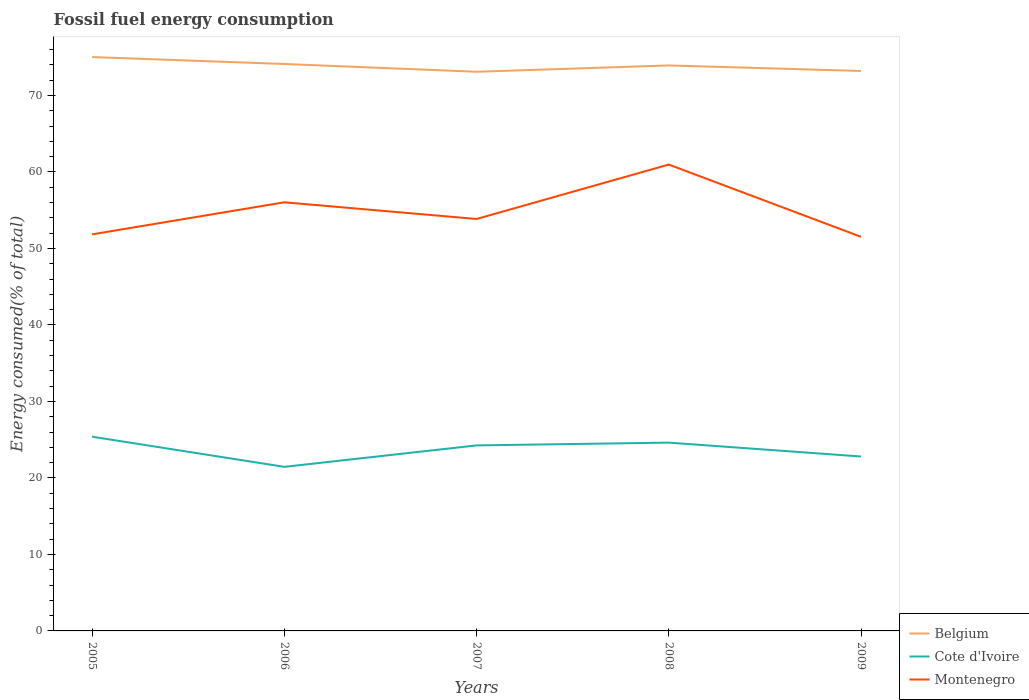Does the line corresponding to Cote d'Ivoire intersect with the line corresponding to Montenegro?
Make the answer very short. No. Across all years, what is the maximum percentage of energy consumed in Cote d'Ivoire?
Your response must be concise. 21.45. What is the total percentage of energy consumed in Belgium in the graph?
Provide a short and direct response. 1.92. What is the difference between the highest and the second highest percentage of energy consumed in Belgium?
Your answer should be very brief. 1.92. What is the difference between the highest and the lowest percentage of energy consumed in Belgium?
Provide a short and direct response. 3. How many lines are there?
Ensure brevity in your answer.  3. How many years are there in the graph?
Your answer should be compact. 5. Where does the legend appear in the graph?
Keep it short and to the point. Bottom right. What is the title of the graph?
Your answer should be very brief. Fossil fuel energy consumption. What is the label or title of the Y-axis?
Offer a terse response. Energy consumed(% of total). What is the Energy consumed(% of total) of Belgium in 2005?
Provide a succinct answer. 75.02. What is the Energy consumed(% of total) of Cote d'Ivoire in 2005?
Make the answer very short. 25.39. What is the Energy consumed(% of total) of Montenegro in 2005?
Offer a very short reply. 51.85. What is the Energy consumed(% of total) of Belgium in 2006?
Make the answer very short. 74.12. What is the Energy consumed(% of total) in Cote d'Ivoire in 2006?
Keep it short and to the point. 21.45. What is the Energy consumed(% of total) in Montenegro in 2006?
Give a very brief answer. 56.03. What is the Energy consumed(% of total) in Belgium in 2007?
Your answer should be very brief. 73.1. What is the Energy consumed(% of total) of Cote d'Ivoire in 2007?
Make the answer very short. 24.25. What is the Energy consumed(% of total) in Montenegro in 2007?
Ensure brevity in your answer.  53.86. What is the Energy consumed(% of total) of Belgium in 2008?
Ensure brevity in your answer.  73.93. What is the Energy consumed(% of total) in Cote d'Ivoire in 2008?
Give a very brief answer. 24.62. What is the Energy consumed(% of total) in Montenegro in 2008?
Your answer should be compact. 60.97. What is the Energy consumed(% of total) of Belgium in 2009?
Your answer should be compact. 73.21. What is the Energy consumed(% of total) of Cote d'Ivoire in 2009?
Provide a short and direct response. 22.8. What is the Energy consumed(% of total) in Montenegro in 2009?
Keep it short and to the point. 51.53. Across all years, what is the maximum Energy consumed(% of total) in Belgium?
Your response must be concise. 75.02. Across all years, what is the maximum Energy consumed(% of total) in Cote d'Ivoire?
Offer a very short reply. 25.39. Across all years, what is the maximum Energy consumed(% of total) of Montenegro?
Keep it short and to the point. 60.97. Across all years, what is the minimum Energy consumed(% of total) in Belgium?
Provide a succinct answer. 73.1. Across all years, what is the minimum Energy consumed(% of total) of Cote d'Ivoire?
Your answer should be compact. 21.45. Across all years, what is the minimum Energy consumed(% of total) in Montenegro?
Provide a short and direct response. 51.53. What is the total Energy consumed(% of total) in Belgium in the graph?
Give a very brief answer. 369.37. What is the total Energy consumed(% of total) in Cote d'Ivoire in the graph?
Give a very brief answer. 118.51. What is the total Energy consumed(% of total) of Montenegro in the graph?
Provide a succinct answer. 274.23. What is the difference between the Energy consumed(% of total) of Belgium in 2005 and that in 2006?
Keep it short and to the point. 0.9. What is the difference between the Energy consumed(% of total) in Cote d'Ivoire in 2005 and that in 2006?
Make the answer very short. 3.94. What is the difference between the Energy consumed(% of total) in Montenegro in 2005 and that in 2006?
Give a very brief answer. -4.19. What is the difference between the Energy consumed(% of total) in Belgium in 2005 and that in 2007?
Provide a succinct answer. 1.92. What is the difference between the Energy consumed(% of total) of Cote d'Ivoire in 2005 and that in 2007?
Ensure brevity in your answer.  1.14. What is the difference between the Energy consumed(% of total) of Montenegro in 2005 and that in 2007?
Ensure brevity in your answer.  -2.01. What is the difference between the Energy consumed(% of total) of Belgium in 2005 and that in 2008?
Give a very brief answer. 1.1. What is the difference between the Energy consumed(% of total) in Cote d'Ivoire in 2005 and that in 2008?
Provide a short and direct response. 0.77. What is the difference between the Energy consumed(% of total) of Montenegro in 2005 and that in 2008?
Offer a terse response. -9.12. What is the difference between the Energy consumed(% of total) in Belgium in 2005 and that in 2009?
Provide a short and direct response. 1.82. What is the difference between the Energy consumed(% of total) of Cote d'Ivoire in 2005 and that in 2009?
Keep it short and to the point. 2.59. What is the difference between the Energy consumed(% of total) in Montenegro in 2005 and that in 2009?
Your response must be concise. 0.32. What is the difference between the Energy consumed(% of total) in Belgium in 2006 and that in 2007?
Offer a terse response. 1.02. What is the difference between the Energy consumed(% of total) in Cote d'Ivoire in 2006 and that in 2007?
Your answer should be very brief. -2.8. What is the difference between the Energy consumed(% of total) in Montenegro in 2006 and that in 2007?
Your response must be concise. 2.18. What is the difference between the Energy consumed(% of total) in Belgium in 2006 and that in 2008?
Offer a terse response. 0.19. What is the difference between the Energy consumed(% of total) in Cote d'Ivoire in 2006 and that in 2008?
Provide a succinct answer. -3.17. What is the difference between the Energy consumed(% of total) of Montenegro in 2006 and that in 2008?
Provide a succinct answer. -4.93. What is the difference between the Energy consumed(% of total) of Belgium in 2006 and that in 2009?
Provide a succinct answer. 0.91. What is the difference between the Energy consumed(% of total) in Cote d'Ivoire in 2006 and that in 2009?
Provide a short and direct response. -1.35. What is the difference between the Energy consumed(% of total) in Montenegro in 2006 and that in 2009?
Make the answer very short. 4.51. What is the difference between the Energy consumed(% of total) of Belgium in 2007 and that in 2008?
Your answer should be very brief. -0.83. What is the difference between the Energy consumed(% of total) in Cote d'Ivoire in 2007 and that in 2008?
Your response must be concise. -0.36. What is the difference between the Energy consumed(% of total) of Montenegro in 2007 and that in 2008?
Your response must be concise. -7.11. What is the difference between the Energy consumed(% of total) of Belgium in 2007 and that in 2009?
Ensure brevity in your answer.  -0.1. What is the difference between the Energy consumed(% of total) of Cote d'Ivoire in 2007 and that in 2009?
Ensure brevity in your answer.  1.45. What is the difference between the Energy consumed(% of total) of Montenegro in 2007 and that in 2009?
Provide a short and direct response. 2.33. What is the difference between the Energy consumed(% of total) of Belgium in 2008 and that in 2009?
Provide a succinct answer. 0.72. What is the difference between the Energy consumed(% of total) in Cote d'Ivoire in 2008 and that in 2009?
Provide a succinct answer. 1.82. What is the difference between the Energy consumed(% of total) of Montenegro in 2008 and that in 2009?
Your response must be concise. 9.44. What is the difference between the Energy consumed(% of total) in Belgium in 2005 and the Energy consumed(% of total) in Cote d'Ivoire in 2006?
Your response must be concise. 53.57. What is the difference between the Energy consumed(% of total) in Belgium in 2005 and the Energy consumed(% of total) in Montenegro in 2006?
Make the answer very short. 18.99. What is the difference between the Energy consumed(% of total) in Cote d'Ivoire in 2005 and the Energy consumed(% of total) in Montenegro in 2006?
Ensure brevity in your answer.  -30.64. What is the difference between the Energy consumed(% of total) in Belgium in 2005 and the Energy consumed(% of total) in Cote d'Ivoire in 2007?
Ensure brevity in your answer.  50.77. What is the difference between the Energy consumed(% of total) of Belgium in 2005 and the Energy consumed(% of total) of Montenegro in 2007?
Give a very brief answer. 21.17. What is the difference between the Energy consumed(% of total) of Cote d'Ivoire in 2005 and the Energy consumed(% of total) of Montenegro in 2007?
Make the answer very short. -28.46. What is the difference between the Energy consumed(% of total) in Belgium in 2005 and the Energy consumed(% of total) in Cote d'Ivoire in 2008?
Your response must be concise. 50.41. What is the difference between the Energy consumed(% of total) in Belgium in 2005 and the Energy consumed(% of total) in Montenegro in 2008?
Your answer should be compact. 14.05. What is the difference between the Energy consumed(% of total) in Cote d'Ivoire in 2005 and the Energy consumed(% of total) in Montenegro in 2008?
Give a very brief answer. -35.58. What is the difference between the Energy consumed(% of total) of Belgium in 2005 and the Energy consumed(% of total) of Cote d'Ivoire in 2009?
Your response must be concise. 52.22. What is the difference between the Energy consumed(% of total) of Belgium in 2005 and the Energy consumed(% of total) of Montenegro in 2009?
Provide a short and direct response. 23.5. What is the difference between the Energy consumed(% of total) of Cote d'Ivoire in 2005 and the Energy consumed(% of total) of Montenegro in 2009?
Offer a terse response. -26.13. What is the difference between the Energy consumed(% of total) in Belgium in 2006 and the Energy consumed(% of total) in Cote d'Ivoire in 2007?
Offer a very short reply. 49.86. What is the difference between the Energy consumed(% of total) in Belgium in 2006 and the Energy consumed(% of total) in Montenegro in 2007?
Offer a terse response. 20.26. What is the difference between the Energy consumed(% of total) in Cote d'Ivoire in 2006 and the Energy consumed(% of total) in Montenegro in 2007?
Your answer should be very brief. -32.41. What is the difference between the Energy consumed(% of total) of Belgium in 2006 and the Energy consumed(% of total) of Cote d'Ivoire in 2008?
Offer a very short reply. 49.5. What is the difference between the Energy consumed(% of total) in Belgium in 2006 and the Energy consumed(% of total) in Montenegro in 2008?
Your answer should be very brief. 13.15. What is the difference between the Energy consumed(% of total) in Cote d'Ivoire in 2006 and the Energy consumed(% of total) in Montenegro in 2008?
Your answer should be very brief. -39.52. What is the difference between the Energy consumed(% of total) in Belgium in 2006 and the Energy consumed(% of total) in Cote d'Ivoire in 2009?
Your response must be concise. 51.32. What is the difference between the Energy consumed(% of total) of Belgium in 2006 and the Energy consumed(% of total) of Montenegro in 2009?
Give a very brief answer. 22.59. What is the difference between the Energy consumed(% of total) of Cote d'Ivoire in 2006 and the Energy consumed(% of total) of Montenegro in 2009?
Make the answer very short. -30.08. What is the difference between the Energy consumed(% of total) of Belgium in 2007 and the Energy consumed(% of total) of Cote d'Ivoire in 2008?
Keep it short and to the point. 48.48. What is the difference between the Energy consumed(% of total) in Belgium in 2007 and the Energy consumed(% of total) in Montenegro in 2008?
Give a very brief answer. 12.13. What is the difference between the Energy consumed(% of total) of Cote d'Ivoire in 2007 and the Energy consumed(% of total) of Montenegro in 2008?
Your answer should be compact. -36.72. What is the difference between the Energy consumed(% of total) of Belgium in 2007 and the Energy consumed(% of total) of Cote d'Ivoire in 2009?
Your answer should be very brief. 50.3. What is the difference between the Energy consumed(% of total) in Belgium in 2007 and the Energy consumed(% of total) in Montenegro in 2009?
Provide a succinct answer. 21.58. What is the difference between the Energy consumed(% of total) in Cote d'Ivoire in 2007 and the Energy consumed(% of total) in Montenegro in 2009?
Provide a succinct answer. -27.27. What is the difference between the Energy consumed(% of total) of Belgium in 2008 and the Energy consumed(% of total) of Cote d'Ivoire in 2009?
Offer a terse response. 51.13. What is the difference between the Energy consumed(% of total) of Belgium in 2008 and the Energy consumed(% of total) of Montenegro in 2009?
Give a very brief answer. 22.4. What is the difference between the Energy consumed(% of total) in Cote d'Ivoire in 2008 and the Energy consumed(% of total) in Montenegro in 2009?
Provide a succinct answer. -26.91. What is the average Energy consumed(% of total) of Belgium per year?
Your answer should be compact. 73.87. What is the average Energy consumed(% of total) of Cote d'Ivoire per year?
Your answer should be compact. 23.7. What is the average Energy consumed(% of total) in Montenegro per year?
Your answer should be very brief. 54.85. In the year 2005, what is the difference between the Energy consumed(% of total) in Belgium and Energy consumed(% of total) in Cote d'Ivoire?
Provide a succinct answer. 49.63. In the year 2005, what is the difference between the Energy consumed(% of total) in Belgium and Energy consumed(% of total) in Montenegro?
Make the answer very short. 23.18. In the year 2005, what is the difference between the Energy consumed(% of total) in Cote d'Ivoire and Energy consumed(% of total) in Montenegro?
Ensure brevity in your answer.  -26.46. In the year 2006, what is the difference between the Energy consumed(% of total) in Belgium and Energy consumed(% of total) in Cote d'Ivoire?
Your answer should be very brief. 52.67. In the year 2006, what is the difference between the Energy consumed(% of total) of Belgium and Energy consumed(% of total) of Montenegro?
Keep it short and to the point. 18.08. In the year 2006, what is the difference between the Energy consumed(% of total) of Cote d'Ivoire and Energy consumed(% of total) of Montenegro?
Your answer should be compact. -34.59. In the year 2007, what is the difference between the Energy consumed(% of total) of Belgium and Energy consumed(% of total) of Cote d'Ivoire?
Your answer should be very brief. 48.85. In the year 2007, what is the difference between the Energy consumed(% of total) of Belgium and Energy consumed(% of total) of Montenegro?
Your answer should be compact. 19.25. In the year 2007, what is the difference between the Energy consumed(% of total) in Cote d'Ivoire and Energy consumed(% of total) in Montenegro?
Ensure brevity in your answer.  -29.6. In the year 2008, what is the difference between the Energy consumed(% of total) of Belgium and Energy consumed(% of total) of Cote d'Ivoire?
Give a very brief answer. 49.31. In the year 2008, what is the difference between the Energy consumed(% of total) in Belgium and Energy consumed(% of total) in Montenegro?
Your response must be concise. 12.96. In the year 2008, what is the difference between the Energy consumed(% of total) in Cote d'Ivoire and Energy consumed(% of total) in Montenegro?
Give a very brief answer. -36.35. In the year 2009, what is the difference between the Energy consumed(% of total) of Belgium and Energy consumed(% of total) of Cote d'Ivoire?
Ensure brevity in your answer.  50.4. In the year 2009, what is the difference between the Energy consumed(% of total) in Belgium and Energy consumed(% of total) in Montenegro?
Keep it short and to the point. 21.68. In the year 2009, what is the difference between the Energy consumed(% of total) in Cote d'Ivoire and Energy consumed(% of total) in Montenegro?
Your response must be concise. -28.72. What is the ratio of the Energy consumed(% of total) of Belgium in 2005 to that in 2006?
Give a very brief answer. 1.01. What is the ratio of the Energy consumed(% of total) in Cote d'Ivoire in 2005 to that in 2006?
Offer a very short reply. 1.18. What is the ratio of the Energy consumed(% of total) of Montenegro in 2005 to that in 2006?
Provide a succinct answer. 0.93. What is the ratio of the Energy consumed(% of total) in Belgium in 2005 to that in 2007?
Provide a short and direct response. 1.03. What is the ratio of the Energy consumed(% of total) in Cote d'Ivoire in 2005 to that in 2007?
Your response must be concise. 1.05. What is the ratio of the Energy consumed(% of total) in Montenegro in 2005 to that in 2007?
Keep it short and to the point. 0.96. What is the ratio of the Energy consumed(% of total) in Belgium in 2005 to that in 2008?
Your answer should be very brief. 1.01. What is the ratio of the Energy consumed(% of total) in Cote d'Ivoire in 2005 to that in 2008?
Keep it short and to the point. 1.03. What is the ratio of the Energy consumed(% of total) of Montenegro in 2005 to that in 2008?
Give a very brief answer. 0.85. What is the ratio of the Energy consumed(% of total) in Belgium in 2005 to that in 2009?
Provide a succinct answer. 1.02. What is the ratio of the Energy consumed(% of total) of Cote d'Ivoire in 2005 to that in 2009?
Make the answer very short. 1.11. What is the ratio of the Energy consumed(% of total) of Belgium in 2006 to that in 2007?
Your answer should be very brief. 1.01. What is the ratio of the Energy consumed(% of total) of Cote d'Ivoire in 2006 to that in 2007?
Provide a short and direct response. 0.88. What is the ratio of the Energy consumed(% of total) in Montenegro in 2006 to that in 2007?
Your response must be concise. 1.04. What is the ratio of the Energy consumed(% of total) of Belgium in 2006 to that in 2008?
Your answer should be compact. 1. What is the ratio of the Energy consumed(% of total) in Cote d'Ivoire in 2006 to that in 2008?
Your answer should be very brief. 0.87. What is the ratio of the Energy consumed(% of total) in Montenegro in 2006 to that in 2008?
Your answer should be very brief. 0.92. What is the ratio of the Energy consumed(% of total) of Belgium in 2006 to that in 2009?
Give a very brief answer. 1.01. What is the ratio of the Energy consumed(% of total) of Cote d'Ivoire in 2006 to that in 2009?
Provide a succinct answer. 0.94. What is the ratio of the Energy consumed(% of total) of Montenegro in 2006 to that in 2009?
Your answer should be compact. 1.09. What is the ratio of the Energy consumed(% of total) of Belgium in 2007 to that in 2008?
Provide a succinct answer. 0.99. What is the ratio of the Energy consumed(% of total) in Cote d'Ivoire in 2007 to that in 2008?
Ensure brevity in your answer.  0.99. What is the ratio of the Energy consumed(% of total) in Montenegro in 2007 to that in 2008?
Your response must be concise. 0.88. What is the ratio of the Energy consumed(% of total) in Cote d'Ivoire in 2007 to that in 2009?
Offer a very short reply. 1.06. What is the ratio of the Energy consumed(% of total) in Montenegro in 2007 to that in 2009?
Provide a short and direct response. 1.05. What is the ratio of the Energy consumed(% of total) of Belgium in 2008 to that in 2009?
Provide a short and direct response. 1.01. What is the ratio of the Energy consumed(% of total) in Cote d'Ivoire in 2008 to that in 2009?
Your answer should be compact. 1.08. What is the ratio of the Energy consumed(% of total) of Montenegro in 2008 to that in 2009?
Provide a short and direct response. 1.18. What is the difference between the highest and the second highest Energy consumed(% of total) in Belgium?
Provide a short and direct response. 0.9. What is the difference between the highest and the second highest Energy consumed(% of total) of Cote d'Ivoire?
Keep it short and to the point. 0.77. What is the difference between the highest and the second highest Energy consumed(% of total) in Montenegro?
Give a very brief answer. 4.93. What is the difference between the highest and the lowest Energy consumed(% of total) of Belgium?
Give a very brief answer. 1.92. What is the difference between the highest and the lowest Energy consumed(% of total) of Cote d'Ivoire?
Provide a short and direct response. 3.94. What is the difference between the highest and the lowest Energy consumed(% of total) in Montenegro?
Ensure brevity in your answer.  9.44. 